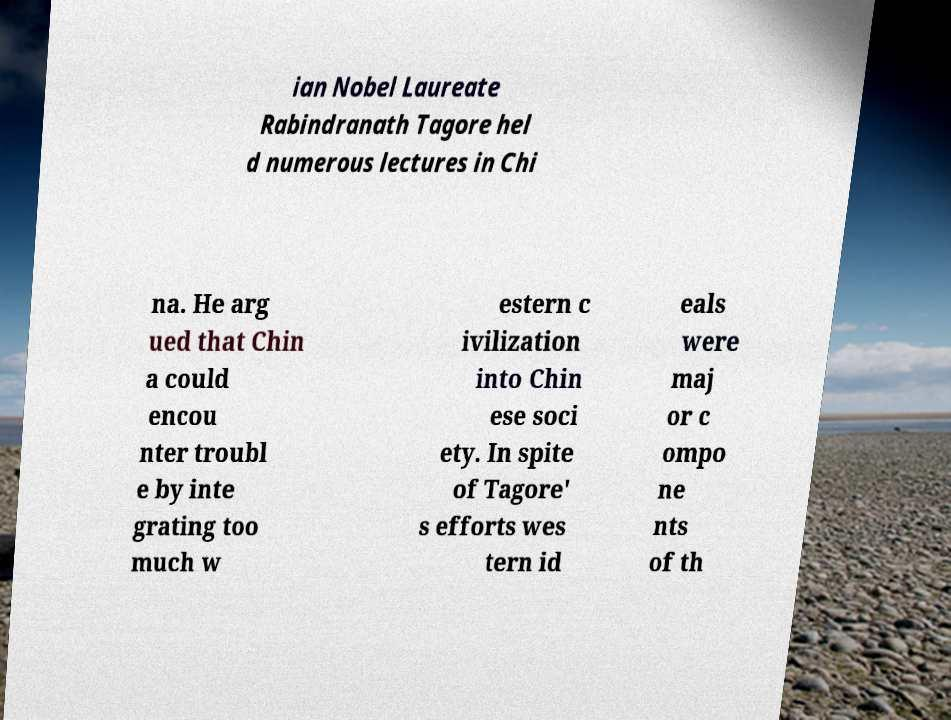For documentation purposes, I need the text within this image transcribed. Could you provide that? ian Nobel Laureate Rabindranath Tagore hel d numerous lectures in Chi na. He arg ued that Chin a could encou nter troubl e by inte grating too much w estern c ivilization into Chin ese soci ety. In spite of Tagore' s efforts wes tern id eals were maj or c ompo ne nts of th 